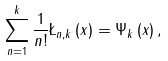Convert formula to latex. <formula><loc_0><loc_0><loc_500><loc_500>\sum _ { n = 1 } ^ { k } \frac { 1 } { n ! } \L _ { n , k } \left ( x \right ) = \Psi _ { k } \left ( x \right ) ,</formula> 